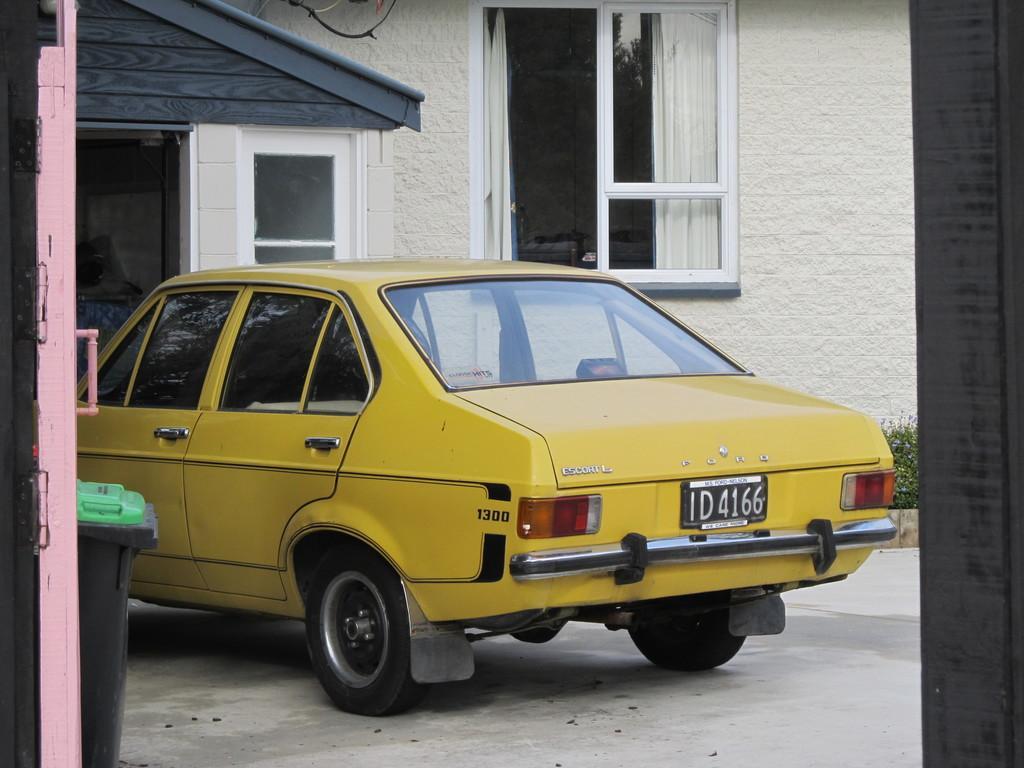How would you summarize this image in a sentence or two? In this image I can see there is a building and a door. And there are dustbin and a wire. And in front there is a car on the ground. And at the side there is a plant with flowers. 